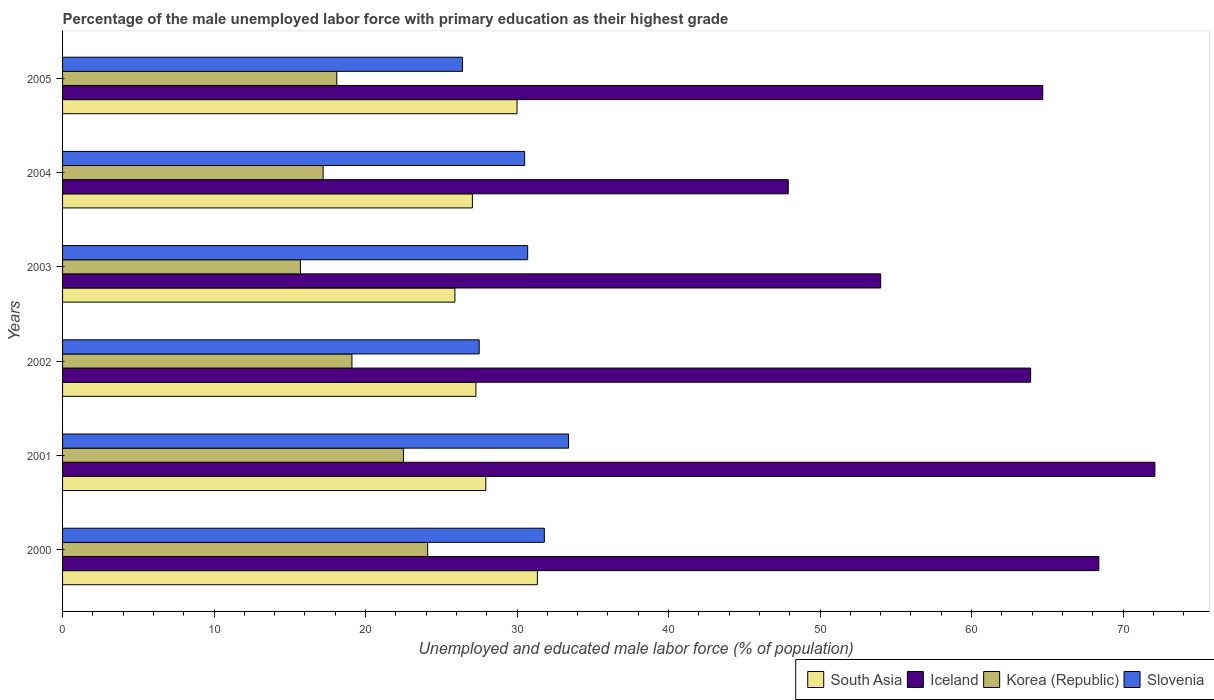How many groups of bars are there?
Ensure brevity in your answer.  6. Are the number of bars per tick equal to the number of legend labels?
Offer a terse response. Yes. What is the label of the 5th group of bars from the top?
Make the answer very short. 2001. What is the percentage of the unemployed male labor force with primary education in South Asia in 2001?
Make the answer very short. 27.94. Across all years, what is the maximum percentage of the unemployed male labor force with primary education in South Asia?
Offer a very short reply. 31.34. Across all years, what is the minimum percentage of the unemployed male labor force with primary education in Korea (Republic)?
Keep it short and to the point. 15.7. In which year was the percentage of the unemployed male labor force with primary education in Slovenia minimum?
Ensure brevity in your answer.  2005. What is the total percentage of the unemployed male labor force with primary education in Slovenia in the graph?
Keep it short and to the point. 180.3. What is the difference between the percentage of the unemployed male labor force with primary education in Slovenia in 2004 and that in 2005?
Your answer should be very brief. 4.1. What is the difference between the percentage of the unemployed male labor force with primary education in Korea (Republic) in 2004 and the percentage of the unemployed male labor force with primary education in Slovenia in 2001?
Offer a terse response. -16.2. What is the average percentage of the unemployed male labor force with primary education in South Asia per year?
Your response must be concise. 28.25. In the year 2001, what is the difference between the percentage of the unemployed male labor force with primary education in South Asia and percentage of the unemployed male labor force with primary education in Slovenia?
Your answer should be compact. -5.46. What is the ratio of the percentage of the unemployed male labor force with primary education in Iceland in 2001 to that in 2002?
Give a very brief answer. 1.13. Is the difference between the percentage of the unemployed male labor force with primary education in South Asia in 2002 and 2004 greater than the difference between the percentage of the unemployed male labor force with primary education in Slovenia in 2002 and 2004?
Give a very brief answer. Yes. What is the difference between the highest and the second highest percentage of the unemployed male labor force with primary education in Slovenia?
Provide a short and direct response. 1.6. What is the difference between the highest and the lowest percentage of the unemployed male labor force with primary education in Slovenia?
Your response must be concise. 7. What does the 3rd bar from the top in 2005 represents?
Offer a very short reply. Iceland. What does the 1st bar from the bottom in 2000 represents?
Provide a succinct answer. South Asia. How many bars are there?
Provide a short and direct response. 24. Are the values on the major ticks of X-axis written in scientific E-notation?
Make the answer very short. No. Where does the legend appear in the graph?
Provide a succinct answer. Bottom right. How many legend labels are there?
Offer a very short reply. 4. What is the title of the graph?
Offer a very short reply. Percentage of the male unemployed labor force with primary education as their highest grade. Does "Libya" appear as one of the legend labels in the graph?
Provide a succinct answer. No. What is the label or title of the X-axis?
Keep it short and to the point. Unemployed and educated male labor force (% of population). What is the label or title of the Y-axis?
Your response must be concise. Years. What is the Unemployed and educated male labor force (% of population) in South Asia in 2000?
Provide a succinct answer. 31.34. What is the Unemployed and educated male labor force (% of population) in Iceland in 2000?
Your answer should be compact. 68.4. What is the Unemployed and educated male labor force (% of population) of Korea (Republic) in 2000?
Offer a terse response. 24.1. What is the Unemployed and educated male labor force (% of population) in Slovenia in 2000?
Make the answer very short. 31.8. What is the Unemployed and educated male labor force (% of population) of South Asia in 2001?
Your answer should be very brief. 27.94. What is the Unemployed and educated male labor force (% of population) of Iceland in 2001?
Offer a terse response. 72.1. What is the Unemployed and educated male labor force (% of population) of Korea (Republic) in 2001?
Your answer should be compact. 22.5. What is the Unemployed and educated male labor force (% of population) of Slovenia in 2001?
Provide a short and direct response. 33.4. What is the Unemployed and educated male labor force (% of population) of South Asia in 2002?
Give a very brief answer. 27.28. What is the Unemployed and educated male labor force (% of population) in Iceland in 2002?
Your response must be concise. 63.9. What is the Unemployed and educated male labor force (% of population) in Korea (Republic) in 2002?
Make the answer very short. 19.1. What is the Unemployed and educated male labor force (% of population) of Slovenia in 2002?
Provide a succinct answer. 27.5. What is the Unemployed and educated male labor force (% of population) in South Asia in 2003?
Offer a terse response. 25.9. What is the Unemployed and educated male labor force (% of population) in Iceland in 2003?
Keep it short and to the point. 54. What is the Unemployed and educated male labor force (% of population) of Korea (Republic) in 2003?
Provide a short and direct response. 15.7. What is the Unemployed and educated male labor force (% of population) in Slovenia in 2003?
Your answer should be compact. 30.7. What is the Unemployed and educated male labor force (% of population) of South Asia in 2004?
Your response must be concise. 27.05. What is the Unemployed and educated male labor force (% of population) in Iceland in 2004?
Your answer should be very brief. 47.9. What is the Unemployed and educated male labor force (% of population) in Korea (Republic) in 2004?
Give a very brief answer. 17.2. What is the Unemployed and educated male labor force (% of population) of Slovenia in 2004?
Offer a terse response. 30.5. What is the Unemployed and educated male labor force (% of population) of South Asia in 2005?
Your answer should be very brief. 30. What is the Unemployed and educated male labor force (% of population) of Iceland in 2005?
Give a very brief answer. 64.7. What is the Unemployed and educated male labor force (% of population) in Korea (Republic) in 2005?
Keep it short and to the point. 18.1. What is the Unemployed and educated male labor force (% of population) in Slovenia in 2005?
Keep it short and to the point. 26.4. Across all years, what is the maximum Unemployed and educated male labor force (% of population) of South Asia?
Your answer should be very brief. 31.34. Across all years, what is the maximum Unemployed and educated male labor force (% of population) of Iceland?
Make the answer very short. 72.1. Across all years, what is the maximum Unemployed and educated male labor force (% of population) of Korea (Republic)?
Provide a succinct answer. 24.1. Across all years, what is the maximum Unemployed and educated male labor force (% of population) in Slovenia?
Your answer should be very brief. 33.4. Across all years, what is the minimum Unemployed and educated male labor force (% of population) in South Asia?
Your answer should be very brief. 25.9. Across all years, what is the minimum Unemployed and educated male labor force (% of population) of Iceland?
Your answer should be very brief. 47.9. Across all years, what is the minimum Unemployed and educated male labor force (% of population) of Korea (Republic)?
Offer a terse response. 15.7. Across all years, what is the minimum Unemployed and educated male labor force (% of population) in Slovenia?
Offer a very short reply. 26.4. What is the total Unemployed and educated male labor force (% of population) of South Asia in the graph?
Provide a succinct answer. 169.51. What is the total Unemployed and educated male labor force (% of population) of Iceland in the graph?
Provide a short and direct response. 371. What is the total Unemployed and educated male labor force (% of population) in Korea (Republic) in the graph?
Your response must be concise. 116.7. What is the total Unemployed and educated male labor force (% of population) in Slovenia in the graph?
Keep it short and to the point. 180.3. What is the difference between the Unemployed and educated male labor force (% of population) in South Asia in 2000 and that in 2001?
Offer a terse response. 3.4. What is the difference between the Unemployed and educated male labor force (% of population) in Iceland in 2000 and that in 2001?
Your answer should be very brief. -3.7. What is the difference between the Unemployed and educated male labor force (% of population) in South Asia in 2000 and that in 2002?
Offer a very short reply. 4.06. What is the difference between the Unemployed and educated male labor force (% of population) in Iceland in 2000 and that in 2002?
Offer a terse response. 4.5. What is the difference between the Unemployed and educated male labor force (% of population) in Korea (Republic) in 2000 and that in 2002?
Offer a very short reply. 5. What is the difference between the Unemployed and educated male labor force (% of population) of Slovenia in 2000 and that in 2002?
Make the answer very short. 4.3. What is the difference between the Unemployed and educated male labor force (% of population) in South Asia in 2000 and that in 2003?
Offer a terse response. 5.44. What is the difference between the Unemployed and educated male labor force (% of population) of Korea (Republic) in 2000 and that in 2003?
Offer a terse response. 8.4. What is the difference between the Unemployed and educated male labor force (% of population) of South Asia in 2000 and that in 2004?
Provide a succinct answer. 4.29. What is the difference between the Unemployed and educated male labor force (% of population) of Iceland in 2000 and that in 2004?
Your response must be concise. 20.5. What is the difference between the Unemployed and educated male labor force (% of population) of Korea (Republic) in 2000 and that in 2004?
Offer a very short reply. 6.9. What is the difference between the Unemployed and educated male labor force (% of population) of South Asia in 2000 and that in 2005?
Offer a very short reply. 1.34. What is the difference between the Unemployed and educated male labor force (% of population) in Iceland in 2000 and that in 2005?
Keep it short and to the point. 3.7. What is the difference between the Unemployed and educated male labor force (% of population) of South Asia in 2001 and that in 2002?
Provide a succinct answer. 0.65. What is the difference between the Unemployed and educated male labor force (% of population) of Iceland in 2001 and that in 2002?
Your response must be concise. 8.2. What is the difference between the Unemployed and educated male labor force (% of population) of Korea (Republic) in 2001 and that in 2002?
Your response must be concise. 3.4. What is the difference between the Unemployed and educated male labor force (% of population) in Slovenia in 2001 and that in 2002?
Your answer should be very brief. 5.9. What is the difference between the Unemployed and educated male labor force (% of population) of South Asia in 2001 and that in 2003?
Give a very brief answer. 2.04. What is the difference between the Unemployed and educated male labor force (% of population) in Iceland in 2001 and that in 2003?
Your answer should be compact. 18.1. What is the difference between the Unemployed and educated male labor force (% of population) of Slovenia in 2001 and that in 2003?
Your response must be concise. 2.7. What is the difference between the Unemployed and educated male labor force (% of population) in South Asia in 2001 and that in 2004?
Your response must be concise. 0.89. What is the difference between the Unemployed and educated male labor force (% of population) in Iceland in 2001 and that in 2004?
Your response must be concise. 24.2. What is the difference between the Unemployed and educated male labor force (% of population) of Korea (Republic) in 2001 and that in 2004?
Offer a terse response. 5.3. What is the difference between the Unemployed and educated male labor force (% of population) of Slovenia in 2001 and that in 2004?
Offer a terse response. 2.9. What is the difference between the Unemployed and educated male labor force (% of population) of South Asia in 2001 and that in 2005?
Your answer should be very brief. -2.06. What is the difference between the Unemployed and educated male labor force (% of population) in Iceland in 2001 and that in 2005?
Offer a terse response. 7.4. What is the difference between the Unemployed and educated male labor force (% of population) of Korea (Republic) in 2001 and that in 2005?
Provide a succinct answer. 4.4. What is the difference between the Unemployed and educated male labor force (% of population) of South Asia in 2002 and that in 2003?
Provide a succinct answer. 1.39. What is the difference between the Unemployed and educated male labor force (% of population) in Iceland in 2002 and that in 2003?
Give a very brief answer. 9.9. What is the difference between the Unemployed and educated male labor force (% of population) in Korea (Republic) in 2002 and that in 2003?
Offer a terse response. 3.4. What is the difference between the Unemployed and educated male labor force (% of population) of South Asia in 2002 and that in 2004?
Keep it short and to the point. 0.23. What is the difference between the Unemployed and educated male labor force (% of population) in Iceland in 2002 and that in 2004?
Give a very brief answer. 16. What is the difference between the Unemployed and educated male labor force (% of population) in Korea (Republic) in 2002 and that in 2004?
Keep it short and to the point. 1.9. What is the difference between the Unemployed and educated male labor force (% of population) of South Asia in 2002 and that in 2005?
Provide a short and direct response. -2.71. What is the difference between the Unemployed and educated male labor force (% of population) of Korea (Republic) in 2002 and that in 2005?
Provide a succinct answer. 1. What is the difference between the Unemployed and educated male labor force (% of population) in South Asia in 2003 and that in 2004?
Offer a very short reply. -1.15. What is the difference between the Unemployed and educated male labor force (% of population) in Korea (Republic) in 2003 and that in 2004?
Offer a very short reply. -1.5. What is the difference between the Unemployed and educated male labor force (% of population) in Slovenia in 2003 and that in 2004?
Your answer should be very brief. 0.2. What is the difference between the Unemployed and educated male labor force (% of population) of South Asia in 2003 and that in 2005?
Offer a terse response. -4.1. What is the difference between the Unemployed and educated male labor force (% of population) in Iceland in 2003 and that in 2005?
Provide a short and direct response. -10.7. What is the difference between the Unemployed and educated male labor force (% of population) in Korea (Republic) in 2003 and that in 2005?
Give a very brief answer. -2.4. What is the difference between the Unemployed and educated male labor force (% of population) of South Asia in 2004 and that in 2005?
Make the answer very short. -2.95. What is the difference between the Unemployed and educated male labor force (% of population) in Iceland in 2004 and that in 2005?
Your answer should be very brief. -16.8. What is the difference between the Unemployed and educated male labor force (% of population) of Korea (Republic) in 2004 and that in 2005?
Your answer should be very brief. -0.9. What is the difference between the Unemployed and educated male labor force (% of population) of Slovenia in 2004 and that in 2005?
Ensure brevity in your answer.  4.1. What is the difference between the Unemployed and educated male labor force (% of population) of South Asia in 2000 and the Unemployed and educated male labor force (% of population) of Iceland in 2001?
Your answer should be compact. -40.76. What is the difference between the Unemployed and educated male labor force (% of population) of South Asia in 2000 and the Unemployed and educated male labor force (% of population) of Korea (Republic) in 2001?
Your answer should be very brief. 8.84. What is the difference between the Unemployed and educated male labor force (% of population) in South Asia in 2000 and the Unemployed and educated male labor force (% of population) in Slovenia in 2001?
Your answer should be very brief. -2.06. What is the difference between the Unemployed and educated male labor force (% of population) in Iceland in 2000 and the Unemployed and educated male labor force (% of population) in Korea (Republic) in 2001?
Your answer should be compact. 45.9. What is the difference between the Unemployed and educated male labor force (% of population) in Korea (Republic) in 2000 and the Unemployed and educated male labor force (% of population) in Slovenia in 2001?
Offer a very short reply. -9.3. What is the difference between the Unemployed and educated male labor force (% of population) of South Asia in 2000 and the Unemployed and educated male labor force (% of population) of Iceland in 2002?
Offer a terse response. -32.56. What is the difference between the Unemployed and educated male labor force (% of population) in South Asia in 2000 and the Unemployed and educated male labor force (% of population) in Korea (Republic) in 2002?
Offer a terse response. 12.24. What is the difference between the Unemployed and educated male labor force (% of population) of South Asia in 2000 and the Unemployed and educated male labor force (% of population) of Slovenia in 2002?
Offer a terse response. 3.84. What is the difference between the Unemployed and educated male labor force (% of population) of Iceland in 2000 and the Unemployed and educated male labor force (% of population) of Korea (Republic) in 2002?
Provide a short and direct response. 49.3. What is the difference between the Unemployed and educated male labor force (% of population) of Iceland in 2000 and the Unemployed and educated male labor force (% of population) of Slovenia in 2002?
Keep it short and to the point. 40.9. What is the difference between the Unemployed and educated male labor force (% of population) in Korea (Republic) in 2000 and the Unemployed and educated male labor force (% of population) in Slovenia in 2002?
Your answer should be very brief. -3.4. What is the difference between the Unemployed and educated male labor force (% of population) in South Asia in 2000 and the Unemployed and educated male labor force (% of population) in Iceland in 2003?
Provide a short and direct response. -22.66. What is the difference between the Unemployed and educated male labor force (% of population) of South Asia in 2000 and the Unemployed and educated male labor force (% of population) of Korea (Republic) in 2003?
Give a very brief answer. 15.64. What is the difference between the Unemployed and educated male labor force (% of population) in South Asia in 2000 and the Unemployed and educated male labor force (% of population) in Slovenia in 2003?
Provide a succinct answer. 0.64. What is the difference between the Unemployed and educated male labor force (% of population) of Iceland in 2000 and the Unemployed and educated male labor force (% of population) of Korea (Republic) in 2003?
Make the answer very short. 52.7. What is the difference between the Unemployed and educated male labor force (% of population) of Iceland in 2000 and the Unemployed and educated male labor force (% of population) of Slovenia in 2003?
Your answer should be compact. 37.7. What is the difference between the Unemployed and educated male labor force (% of population) in South Asia in 2000 and the Unemployed and educated male labor force (% of population) in Iceland in 2004?
Ensure brevity in your answer.  -16.56. What is the difference between the Unemployed and educated male labor force (% of population) in South Asia in 2000 and the Unemployed and educated male labor force (% of population) in Korea (Republic) in 2004?
Make the answer very short. 14.14. What is the difference between the Unemployed and educated male labor force (% of population) of South Asia in 2000 and the Unemployed and educated male labor force (% of population) of Slovenia in 2004?
Offer a very short reply. 0.84. What is the difference between the Unemployed and educated male labor force (% of population) of Iceland in 2000 and the Unemployed and educated male labor force (% of population) of Korea (Republic) in 2004?
Provide a short and direct response. 51.2. What is the difference between the Unemployed and educated male labor force (% of population) in Iceland in 2000 and the Unemployed and educated male labor force (% of population) in Slovenia in 2004?
Your response must be concise. 37.9. What is the difference between the Unemployed and educated male labor force (% of population) of South Asia in 2000 and the Unemployed and educated male labor force (% of population) of Iceland in 2005?
Offer a terse response. -33.36. What is the difference between the Unemployed and educated male labor force (% of population) of South Asia in 2000 and the Unemployed and educated male labor force (% of population) of Korea (Republic) in 2005?
Your response must be concise. 13.24. What is the difference between the Unemployed and educated male labor force (% of population) of South Asia in 2000 and the Unemployed and educated male labor force (% of population) of Slovenia in 2005?
Ensure brevity in your answer.  4.94. What is the difference between the Unemployed and educated male labor force (% of population) of Iceland in 2000 and the Unemployed and educated male labor force (% of population) of Korea (Republic) in 2005?
Make the answer very short. 50.3. What is the difference between the Unemployed and educated male labor force (% of population) in Korea (Republic) in 2000 and the Unemployed and educated male labor force (% of population) in Slovenia in 2005?
Provide a succinct answer. -2.3. What is the difference between the Unemployed and educated male labor force (% of population) of South Asia in 2001 and the Unemployed and educated male labor force (% of population) of Iceland in 2002?
Provide a short and direct response. -35.96. What is the difference between the Unemployed and educated male labor force (% of population) of South Asia in 2001 and the Unemployed and educated male labor force (% of population) of Korea (Republic) in 2002?
Your answer should be very brief. 8.84. What is the difference between the Unemployed and educated male labor force (% of population) in South Asia in 2001 and the Unemployed and educated male labor force (% of population) in Slovenia in 2002?
Your answer should be compact. 0.44. What is the difference between the Unemployed and educated male labor force (% of population) of Iceland in 2001 and the Unemployed and educated male labor force (% of population) of Korea (Republic) in 2002?
Provide a short and direct response. 53. What is the difference between the Unemployed and educated male labor force (% of population) in Iceland in 2001 and the Unemployed and educated male labor force (% of population) in Slovenia in 2002?
Offer a terse response. 44.6. What is the difference between the Unemployed and educated male labor force (% of population) in South Asia in 2001 and the Unemployed and educated male labor force (% of population) in Iceland in 2003?
Provide a succinct answer. -26.06. What is the difference between the Unemployed and educated male labor force (% of population) in South Asia in 2001 and the Unemployed and educated male labor force (% of population) in Korea (Republic) in 2003?
Provide a succinct answer. 12.24. What is the difference between the Unemployed and educated male labor force (% of population) of South Asia in 2001 and the Unemployed and educated male labor force (% of population) of Slovenia in 2003?
Your response must be concise. -2.76. What is the difference between the Unemployed and educated male labor force (% of population) of Iceland in 2001 and the Unemployed and educated male labor force (% of population) of Korea (Republic) in 2003?
Your answer should be compact. 56.4. What is the difference between the Unemployed and educated male labor force (% of population) of Iceland in 2001 and the Unemployed and educated male labor force (% of population) of Slovenia in 2003?
Offer a terse response. 41.4. What is the difference between the Unemployed and educated male labor force (% of population) in Korea (Republic) in 2001 and the Unemployed and educated male labor force (% of population) in Slovenia in 2003?
Provide a succinct answer. -8.2. What is the difference between the Unemployed and educated male labor force (% of population) in South Asia in 2001 and the Unemployed and educated male labor force (% of population) in Iceland in 2004?
Make the answer very short. -19.96. What is the difference between the Unemployed and educated male labor force (% of population) of South Asia in 2001 and the Unemployed and educated male labor force (% of population) of Korea (Republic) in 2004?
Keep it short and to the point. 10.74. What is the difference between the Unemployed and educated male labor force (% of population) in South Asia in 2001 and the Unemployed and educated male labor force (% of population) in Slovenia in 2004?
Offer a terse response. -2.56. What is the difference between the Unemployed and educated male labor force (% of population) in Iceland in 2001 and the Unemployed and educated male labor force (% of population) in Korea (Republic) in 2004?
Ensure brevity in your answer.  54.9. What is the difference between the Unemployed and educated male labor force (% of population) in Iceland in 2001 and the Unemployed and educated male labor force (% of population) in Slovenia in 2004?
Keep it short and to the point. 41.6. What is the difference between the Unemployed and educated male labor force (% of population) of Korea (Republic) in 2001 and the Unemployed and educated male labor force (% of population) of Slovenia in 2004?
Keep it short and to the point. -8. What is the difference between the Unemployed and educated male labor force (% of population) of South Asia in 2001 and the Unemployed and educated male labor force (% of population) of Iceland in 2005?
Your response must be concise. -36.76. What is the difference between the Unemployed and educated male labor force (% of population) in South Asia in 2001 and the Unemployed and educated male labor force (% of population) in Korea (Republic) in 2005?
Make the answer very short. 9.84. What is the difference between the Unemployed and educated male labor force (% of population) in South Asia in 2001 and the Unemployed and educated male labor force (% of population) in Slovenia in 2005?
Ensure brevity in your answer.  1.54. What is the difference between the Unemployed and educated male labor force (% of population) in Iceland in 2001 and the Unemployed and educated male labor force (% of population) in Slovenia in 2005?
Your answer should be compact. 45.7. What is the difference between the Unemployed and educated male labor force (% of population) in South Asia in 2002 and the Unemployed and educated male labor force (% of population) in Iceland in 2003?
Provide a short and direct response. -26.72. What is the difference between the Unemployed and educated male labor force (% of population) of South Asia in 2002 and the Unemployed and educated male labor force (% of population) of Korea (Republic) in 2003?
Provide a short and direct response. 11.58. What is the difference between the Unemployed and educated male labor force (% of population) of South Asia in 2002 and the Unemployed and educated male labor force (% of population) of Slovenia in 2003?
Keep it short and to the point. -3.42. What is the difference between the Unemployed and educated male labor force (% of population) of Iceland in 2002 and the Unemployed and educated male labor force (% of population) of Korea (Republic) in 2003?
Your answer should be very brief. 48.2. What is the difference between the Unemployed and educated male labor force (% of population) in Iceland in 2002 and the Unemployed and educated male labor force (% of population) in Slovenia in 2003?
Your answer should be very brief. 33.2. What is the difference between the Unemployed and educated male labor force (% of population) of South Asia in 2002 and the Unemployed and educated male labor force (% of population) of Iceland in 2004?
Give a very brief answer. -20.62. What is the difference between the Unemployed and educated male labor force (% of population) in South Asia in 2002 and the Unemployed and educated male labor force (% of population) in Korea (Republic) in 2004?
Offer a terse response. 10.08. What is the difference between the Unemployed and educated male labor force (% of population) of South Asia in 2002 and the Unemployed and educated male labor force (% of population) of Slovenia in 2004?
Give a very brief answer. -3.22. What is the difference between the Unemployed and educated male labor force (% of population) in Iceland in 2002 and the Unemployed and educated male labor force (% of population) in Korea (Republic) in 2004?
Offer a terse response. 46.7. What is the difference between the Unemployed and educated male labor force (% of population) of Iceland in 2002 and the Unemployed and educated male labor force (% of population) of Slovenia in 2004?
Provide a short and direct response. 33.4. What is the difference between the Unemployed and educated male labor force (% of population) of Korea (Republic) in 2002 and the Unemployed and educated male labor force (% of population) of Slovenia in 2004?
Give a very brief answer. -11.4. What is the difference between the Unemployed and educated male labor force (% of population) in South Asia in 2002 and the Unemployed and educated male labor force (% of population) in Iceland in 2005?
Your answer should be compact. -37.42. What is the difference between the Unemployed and educated male labor force (% of population) of South Asia in 2002 and the Unemployed and educated male labor force (% of population) of Korea (Republic) in 2005?
Offer a terse response. 9.18. What is the difference between the Unemployed and educated male labor force (% of population) of South Asia in 2002 and the Unemployed and educated male labor force (% of population) of Slovenia in 2005?
Provide a succinct answer. 0.88. What is the difference between the Unemployed and educated male labor force (% of population) of Iceland in 2002 and the Unemployed and educated male labor force (% of population) of Korea (Republic) in 2005?
Your answer should be very brief. 45.8. What is the difference between the Unemployed and educated male labor force (% of population) in Iceland in 2002 and the Unemployed and educated male labor force (% of population) in Slovenia in 2005?
Give a very brief answer. 37.5. What is the difference between the Unemployed and educated male labor force (% of population) in Korea (Republic) in 2002 and the Unemployed and educated male labor force (% of population) in Slovenia in 2005?
Ensure brevity in your answer.  -7.3. What is the difference between the Unemployed and educated male labor force (% of population) in South Asia in 2003 and the Unemployed and educated male labor force (% of population) in Iceland in 2004?
Your answer should be very brief. -22. What is the difference between the Unemployed and educated male labor force (% of population) in South Asia in 2003 and the Unemployed and educated male labor force (% of population) in Korea (Republic) in 2004?
Make the answer very short. 8.7. What is the difference between the Unemployed and educated male labor force (% of population) in South Asia in 2003 and the Unemployed and educated male labor force (% of population) in Slovenia in 2004?
Make the answer very short. -4.6. What is the difference between the Unemployed and educated male labor force (% of population) of Iceland in 2003 and the Unemployed and educated male labor force (% of population) of Korea (Republic) in 2004?
Your response must be concise. 36.8. What is the difference between the Unemployed and educated male labor force (% of population) of Iceland in 2003 and the Unemployed and educated male labor force (% of population) of Slovenia in 2004?
Offer a terse response. 23.5. What is the difference between the Unemployed and educated male labor force (% of population) in Korea (Republic) in 2003 and the Unemployed and educated male labor force (% of population) in Slovenia in 2004?
Provide a succinct answer. -14.8. What is the difference between the Unemployed and educated male labor force (% of population) of South Asia in 2003 and the Unemployed and educated male labor force (% of population) of Iceland in 2005?
Keep it short and to the point. -38.8. What is the difference between the Unemployed and educated male labor force (% of population) of South Asia in 2003 and the Unemployed and educated male labor force (% of population) of Korea (Republic) in 2005?
Offer a terse response. 7.8. What is the difference between the Unemployed and educated male labor force (% of population) in South Asia in 2003 and the Unemployed and educated male labor force (% of population) in Slovenia in 2005?
Give a very brief answer. -0.5. What is the difference between the Unemployed and educated male labor force (% of population) in Iceland in 2003 and the Unemployed and educated male labor force (% of population) in Korea (Republic) in 2005?
Your answer should be very brief. 35.9. What is the difference between the Unemployed and educated male labor force (% of population) of Iceland in 2003 and the Unemployed and educated male labor force (% of population) of Slovenia in 2005?
Provide a short and direct response. 27.6. What is the difference between the Unemployed and educated male labor force (% of population) in Korea (Republic) in 2003 and the Unemployed and educated male labor force (% of population) in Slovenia in 2005?
Offer a terse response. -10.7. What is the difference between the Unemployed and educated male labor force (% of population) of South Asia in 2004 and the Unemployed and educated male labor force (% of population) of Iceland in 2005?
Your answer should be very brief. -37.65. What is the difference between the Unemployed and educated male labor force (% of population) of South Asia in 2004 and the Unemployed and educated male labor force (% of population) of Korea (Republic) in 2005?
Provide a short and direct response. 8.95. What is the difference between the Unemployed and educated male labor force (% of population) of South Asia in 2004 and the Unemployed and educated male labor force (% of population) of Slovenia in 2005?
Your response must be concise. 0.65. What is the difference between the Unemployed and educated male labor force (% of population) in Iceland in 2004 and the Unemployed and educated male labor force (% of population) in Korea (Republic) in 2005?
Offer a very short reply. 29.8. What is the difference between the Unemployed and educated male labor force (% of population) of Korea (Republic) in 2004 and the Unemployed and educated male labor force (% of population) of Slovenia in 2005?
Provide a succinct answer. -9.2. What is the average Unemployed and educated male labor force (% of population) in South Asia per year?
Ensure brevity in your answer.  28.25. What is the average Unemployed and educated male labor force (% of population) in Iceland per year?
Your answer should be very brief. 61.83. What is the average Unemployed and educated male labor force (% of population) in Korea (Republic) per year?
Your response must be concise. 19.45. What is the average Unemployed and educated male labor force (% of population) of Slovenia per year?
Your answer should be very brief. 30.05. In the year 2000, what is the difference between the Unemployed and educated male labor force (% of population) of South Asia and Unemployed and educated male labor force (% of population) of Iceland?
Make the answer very short. -37.06. In the year 2000, what is the difference between the Unemployed and educated male labor force (% of population) in South Asia and Unemployed and educated male labor force (% of population) in Korea (Republic)?
Provide a succinct answer. 7.24. In the year 2000, what is the difference between the Unemployed and educated male labor force (% of population) in South Asia and Unemployed and educated male labor force (% of population) in Slovenia?
Provide a succinct answer. -0.46. In the year 2000, what is the difference between the Unemployed and educated male labor force (% of population) of Iceland and Unemployed and educated male labor force (% of population) of Korea (Republic)?
Ensure brevity in your answer.  44.3. In the year 2000, what is the difference between the Unemployed and educated male labor force (% of population) in Iceland and Unemployed and educated male labor force (% of population) in Slovenia?
Offer a very short reply. 36.6. In the year 2000, what is the difference between the Unemployed and educated male labor force (% of population) of Korea (Republic) and Unemployed and educated male labor force (% of population) of Slovenia?
Your answer should be very brief. -7.7. In the year 2001, what is the difference between the Unemployed and educated male labor force (% of population) in South Asia and Unemployed and educated male labor force (% of population) in Iceland?
Ensure brevity in your answer.  -44.16. In the year 2001, what is the difference between the Unemployed and educated male labor force (% of population) of South Asia and Unemployed and educated male labor force (% of population) of Korea (Republic)?
Provide a short and direct response. 5.44. In the year 2001, what is the difference between the Unemployed and educated male labor force (% of population) of South Asia and Unemployed and educated male labor force (% of population) of Slovenia?
Provide a short and direct response. -5.46. In the year 2001, what is the difference between the Unemployed and educated male labor force (% of population) in Iceland and Unemployed and educated male labor force (% of population) in Korea (Republic)?
Offer a very short reply. 49.6. In the year 2001, what is the difference between the Unemployed and educated male labor force (% of population) in Iceland and Unemployed and educated male labor force (% of population) in Slovenia?
Provide a short and direct response. 38.7. In the year 2001, what is the difference between the Unemployed and educated male labor force (% of population) of Korea (Republic) and Unemployed and educated male labor force (% of population) of Slovenia?
Provide a succinct answer. -10.9. In the year 2002, what is the difference between the Unemployed and educated male labor force (% of population) in South Asia and Unemployed and educated male labor force (% of population) in Iceland?
Offer a terse response. -36.62. In the year 2002, what is the difference between the Unemployed and educated male labor force (% of population) in South Asia and Unemployed and educated male labor force (% of population) in Korea (Republic)?
Offer a very short reply. 8.18. In the year 2002, what is the difference between the Unemployed and educated male labor force (% of population) in South Asia and Unemployed and educated male labor force (% of population) in Slovenia?
Provide a succinct answer. -0.22. In the year 2002, what is the difference between the Unemployed and educated male labor force (% of population) in Iceland and Unemployed and educated male labor force (% of population) in Korea (Republic)?
Make the answer very short. 44.8. In the year 2002, what is the difference between the Unemployed and educated male labor force (% of population) of Iceland and Unemployed and educated male labor force (% of population) of Slovenia?
Make the answer very short. 36.4. In the year 2002, what is the difference between the Unemployed and educated male labor force (% of population) of Korea (Republic) and Unemployed and educated male labor force (% of population) of Slovenia?
Make the answer very short. -8.4. In the year 2003, what is the difference between the Unemployed and educated male labor force (% of population) in South Asia and Unemployed and educated male labor force (% of population) in Iceland?
Your answer should be compact. -28.1. In the year 2003, what is the difference between the Unemployed and educated male labor force (% of population) of South Asia and Unemployed and educated male labor force (% of population) of Korea (Republic)?
Keep it short and to the point. 10.2. In the year 2003, what is the difference between the Unemployed and educated male labor force (% of population) of South Asia and Unemployed and educated male labor force (% of population) of Slovenia?
Your response must be concise. -4.8. In the year 2003, what is the difference between the Unemployed and educated male labor force (% of population) of Iceland and Unemployed and educated male labor force (% of population) of Korea (Republic)?
Keep it short and to the point. 38.3. In the year 2003, what is the difference between the Unemployed and educated male labor force (% of population) of Iceland and Unemployed and educated male labor force (% of population) of Slovenia?
Offer a very short reply. 23.3. In the year 2003, what is the difference between the Unemployed and educated male labor force (% of population) in Korea (Republic) and Unemployed and educated male labor force (% of population) in Slovenia?
Make the answer very short. -15. In the year 2004, what is the difference between the Unemployed and educated male labor force (% of population) in South Asia and Unemployed and educated male labor force (% of population) in Iceland?
Offer a very short reply. -20.85. In the year 2004, what is the difference between the Unemployed and educated male labor force (% of population) of South Asia and Unemployed and educated male labor force (% of population) of Korea (Republic)?
Your answer should be very brief. 9.85. In the year 2004, what is the difference between the Unemployed and educated male labor force (% of population) of South Asia and Unemployed and educated male labor force (% of population) of Slovenia?
Your answer should be very brief. -3.45. In the year 2004, what is the difference between the Unemployed and educated male labor force (% of population) in Iceland and Unemployed and educated male labor force (% of population) in Korea (Republic)?
Your response must be concise. 30.7. In the year 2004, what is the difference between the Unemployed and educated male labor force (% of population) in Iceland and Unemployed and educated male labor force (% of population) in Slovenia?
Your answer should be compact. 17.4. In the year 2004, what is the difference between the Unemployed and educated male labor force (% of population) in Korea (Republic) and Unemployed and educated male labor force (% of population) in Slovenia?
Provide a short and direct response. -13.3. In the year 2005, what is the difference between the Unemployed and educated male labor force (% of population) of South Asia and Unemployed and educated male labor force (% of population) of Iceland?
Make the answer very short. -34.7. In the year 2005, what is the difference between the Unemployed and educated male labor force (% of population) in South Asia and Unemployed and educated male labor force (% of population) in Korea (Republic)?
Provide a short and direct response. 11.9. In the year 2005, what is the difference between the Unemployed and educated male labor force (% of population) of South Asia and Unemployed and educated male labor force (% of population) of Slovenia?
Offer a terse response. 3.6. In the year 2005, what is the difference between the Unemployed and educated male labor force (% of population) of Iceland and Unemployed and educated male labor force (% of population) of Korea (Republic)?
Keep it short and to the point. 46.6. In the year 2005, what is the difference between the Unemployed and educated male labor force (% of population) in Iceland and Unemployed and educated male labor force (% of population) in Slovenia?
Ensure brevity in your answer.  38.3. In the year 2005, what is the difference between the Unemployed and educated male labor force (% of population) in Korea (Republic) and Unemployed and educated male labor force (% of population) in Slovenia?
Provide a succinct answer. -8.3. What is the ratio of the Unemployed and educated male labor force (% of population) of South Asia in 2000 to that in 2001?
Give a very brief answer. 1.12. What is the ratio of the Unemployed and educated male labor force (% of population) of Iceland in 2000 to that in 2001?
Offer a very short reply. 0.95. What is the ratio of the Unemployed and educated male labor force (% of population) of Korea (Republic) in 2000 to that in 2001?
Provide a short and direct response. 1.07. What is the ratio of the Unemployed and educated male labor force (% of population) in Slovenia in 2000 to that in 2001?
Provide a short and direct response. 0.95. What is the ratio of the Unemployed and educated male labor force (% of population) of South Asia in 2000 to that in 2002?
Make the answer very short. 1.15. What is the ratio of the Unemployed and educated male labor force (% of population) of Iceland in 2000 to that in 2002?
Offer a very short reply. 1.07. What is the ratio of the Unemployed and educated male labor force (% of population) of Korea (Republic) in 2000 to that in 2002?
Keep it short and to the point. 1.26. What is the ratio of the Unemployed and educated male labor force (% of population) of Slovenia in 2000 to that in 2002?
Your answer should be compact. 1.16. What is the ratio of the Unemployed and educated male labor force (% of population) in South Asia in 2000 to that in 2003?
Give a very brief answer. 1.21. What is the ratio of the Unemployed and educated male labor force (% of population) of Iceland in 2000 to that in 2003?
Keep it short and to the point. 1.27. What is the ratio of the Unemployed and educated male labor force (% of population) of Korea (Republic) in 2000 to that in 2003?
Provide a succinct answer. 1.53. What is the ratio of the Unemployed and educated male labor force (% of population) in Slovenia in 2000 to that in 2003?
Your answer should be very brief. 1.04. What is the ratio of the Unemployed and educated male labor force (% of population) in South Asia in 2000 to that in 2004?
Your answer should be very brief. 1.16. What is the ratio of the Unemployed and educated male labor force (% of population) in Iceland in 2000 to that in 2004?
Your answer should be very brief. 1.43. What is the ratio of the Unemployed and educated male labor force (% of population) of Korea (Republic) in 2000 to that in 2004?
Keep it short and to the point. 1.4. What is the ratio of the Unemployed and educated male labor force (% of population) in Slovenia in 2000 to that in 2004?
Give a very brief answer. 1.04. What is the ratio of the Unemployed and educated male labor force (% of population) in South Asia in 2000 to that in 2005?
Give a very brief answer. 1.04. What is the ratio of the Unemployed and educated male labor force (% of population) of Iceland in 2000 to that in 2005?
Keep it short and to the point. 1.06. What is the ratio of the Unemployed and educated male labor force (% of population) of Korea (Republic) in 2000 to that in 2005?
Offer a very short reply. 1.33. What is the ratio of the Unemployed and educated male labor force (% of population) in Slovenia in 2000 to that in 2005?
Offer a very short reply. 1.2. What is the ratio of the Unemployed and educated male labor force (% of population) of South Asia in 2001 to that in 2002?
Your answer should be very brief. 1.02. What is the ratio of the Unemployed and educated male labor force (% of population) of Iceland in 2001 to that in 2002?
Your answer should be very brief. 1.13. What is the ratio of the Unemployed and educated male labor force (% of population) in Korea (Republic) in 2001 to that in 2002?
Offer a terse response. 1.18. What is the ratio of the Unemployed and educated male labor force (% of population) of Slovenia in 2001 to that in 2002?
Ensure brevity in your answer.  1.21. What is the ratio of the Unemployed and educated male labor force (% of population) of South Asia in 2001 to that in 2003?
Offer a very short reply. 1.08. What is the ratio of the Unemployed and educated male labor force (% of population) in Iceland in 2001 to that in 2003?
Provide a short and direct response. 1.34. What is the ratio of the Unemployed and educated male labor force (% of population) in Korea (Republic) in 2001 to that in 2003?
Offer a very short reply. 1.43. What is the ratio of the Unemployed and educated male labor force (% of population) in Slovenia in 2001 to that in 2003?
Ensure brevity in your answer.  1.09. What is the ratio of the Unemployed and educated male labor force (% of population) of South Asia in 2001 to that in 2004?
Provide a succinct answer. 1.03. What is the ratio of the Unemployed and educated male labor force (% of population) in Iceland in 2001 to that in 2004?
Keep it short and to the point. 1.51. What is the ratio of the Unemployed and educated male labor force (% of population) of Korea (Republic) in 2001 to that in 2004?
Your answer should be compact. 1.31. What is the ratio of the Unemployed and educated male labor force (% of population) in Slovenia in 2001 to that in 2004?
Give a very brief answer. 1.1. What is the ratio of the Unemployed and educated male labor force (% of population) of South Asia in 2001 to that in 2005?
Offer a terse response. 0.93. What is the ratio of the Unemployed and educated male labor force (% of population) in Iceland in 2001 to that in 2005?
Your answer should be very brief. 1.11. What is the ratio of the Unemployed and educated male labor force (% of population) of Korea (Republic) in 2001 to that in 2005?
Provide a short and direct response. 1.24. What is the ratio of the Unemployed and educated male labor force (% of population) in Slovenia in 2001 to that in 2005?
Offer a very short reply. 1.27. What is the ratio of the Unemployed and educated male labor force (% of population) of South Asia in 2002 to that in 2003?
Your answer should be compact. 1.05. What is the ratio of the Unemployed and educated male labor force (% of population) in Iceland in 2002 to that in 2003?
Provide a succinct answer. 1.18. What is the ratio of the Unemployed and educated male labor force (% of population) of Korea (Republic) in 2002 to that in 2003?
Ensure brevity in your answer.  1.22. What is the ratio of the Unemployed and educated male labor force (% of population) of Slovenia in 2002 to that in 2003?
Ensure brevity in your answer.  0.9. What is the ratio of the Unemployed and educated male labor force (% of population) in South Asia in 2002 to that in 2004?
Your answer should be compact. 1.01. What is the ratio of the Unemployed and educated male labor force (% of population) in Iceland in 2002 to that in 2004?
Give a very brief answer. 1.33. What is the ratio of the Unemployed and educated male labor force (% of population) in Korea (Republic) in 2002 to that in 2004?
Give a very brief answer. 1.11. What is the ratio of the Unemployed and educated male labor force (% of population) of Slovenia in 2002 to that in 2004?
Make the answer very short. 0.9. What is the ratio of the Unemployed and educated male labor force (% of population) of South Asia in 2002 to that in 2005?
Offer a terse response. 0.91. What is the ratio of the Unemployed and educated male labor force (% of population) in Iceland in 2002 to that in 2005?
Make the answer very short. 0.99. What is the ratio of the Unemployed and educated male labor force (% of population) in Korea (Republic) in 2002 to that in 2005?
Make the answer very short. 1.06. What is the ratio of the Unemployed and educated male labor force (% of population) in Slovenia in 2002 to that in 2005?
Your answer should be very brief. 1.04. What is the ratio of the Unemployed and educated male labor force (% of population) in South Asia in 2003 to that in 2004?
Your answer should be very brief. 0.96. What is the ratio of the Unemployed and educated male labor force (% of population) of Iceland in 2003 to that in 2004?
Provide a succinct answer. 1.13. What is the ratio of the Unemployed and educated male labor force (% of population) in Korea (Republic) in 2003 to that in 2004?
Offer a very short reply. 0.91. What is the ratio of the Unemployed and educated male labor force (% of population) in Slovenia in 2003 to that in 2004?
Provide a short and direct response. 1.01. What is the ratio of the Unemployed and educated male labor force (% of population) in South Asia in 2003 to that in 2005?
Your answer should be very brief. 0.86. What is the ratio of the Unemployed and educated male labor force (% of population) of Iceland in 2003 to that in 2005?
Make the answer very short. 0.83. What is the ratio of the Unemployed and educated male labor force (% of population) of Korea (Republic) in 2003 to that in 2005?
Your answer should be very brief. 0.87. What is the ratio of the Unemployed and educated male labor force (% of population) in Slovenia in 2003 to that in 2005?
Offer a very short reply. 1.16. What is the ratio of the Unemployed and educated male labor force (% of population) of South Asia in 2004 to that in 2005?
Make the answer very short. 0.9. What is the ratio of the Unemployed and educated male labor force (% of population) in Iceland in 2004 to that in 2005?
Provide a short and direct response. 0.74. What is the ratio of the Unemployed and educated male labor force (% of population) in Korea (Republic) in 2004 to that in 2005?
Offer a very short reply. 0.95. What is the ratio of the Unemployed and educated male labor force (% of population) of Slovenia in 2004 to that in 2005?
Offer a terse response. 1.16. What is the difference between the highest and the second highest Unemployed and educated male labor force (% of population) in South Asia?
Keep it short and to the point. 1.34. What is the difference between the highest and the second highest Unemployed and educated male labor force (% of population) in Iceland?
Make the answer very short. 3.7. What is the difference between the highest and the second highest Unemployed and educated male labor force (% of population) in Slovenia?
Offer a very short reply. 1.6. What is the difference between the highest and the lowest Unemployed and educated male labor force (% of population) in South Asia?
Ensure brevity in your answer.  5.44. What is the difference between the highest and the lowest Unemployed and educated male labor force (% of population) in Iceland?
Provide a succinct answer. 24.2. What is the difference between the highest and the lowest Unemployed and educated male labor force (% of population) in Korea (Republic)?
Make the answer very short. 8.4. 